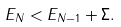Convert formula to latex. <formula><loc_0><loc_0><loc_500><loc_500>E _ { N } < E _ { N - 1 } + \Sigma .</formula> 